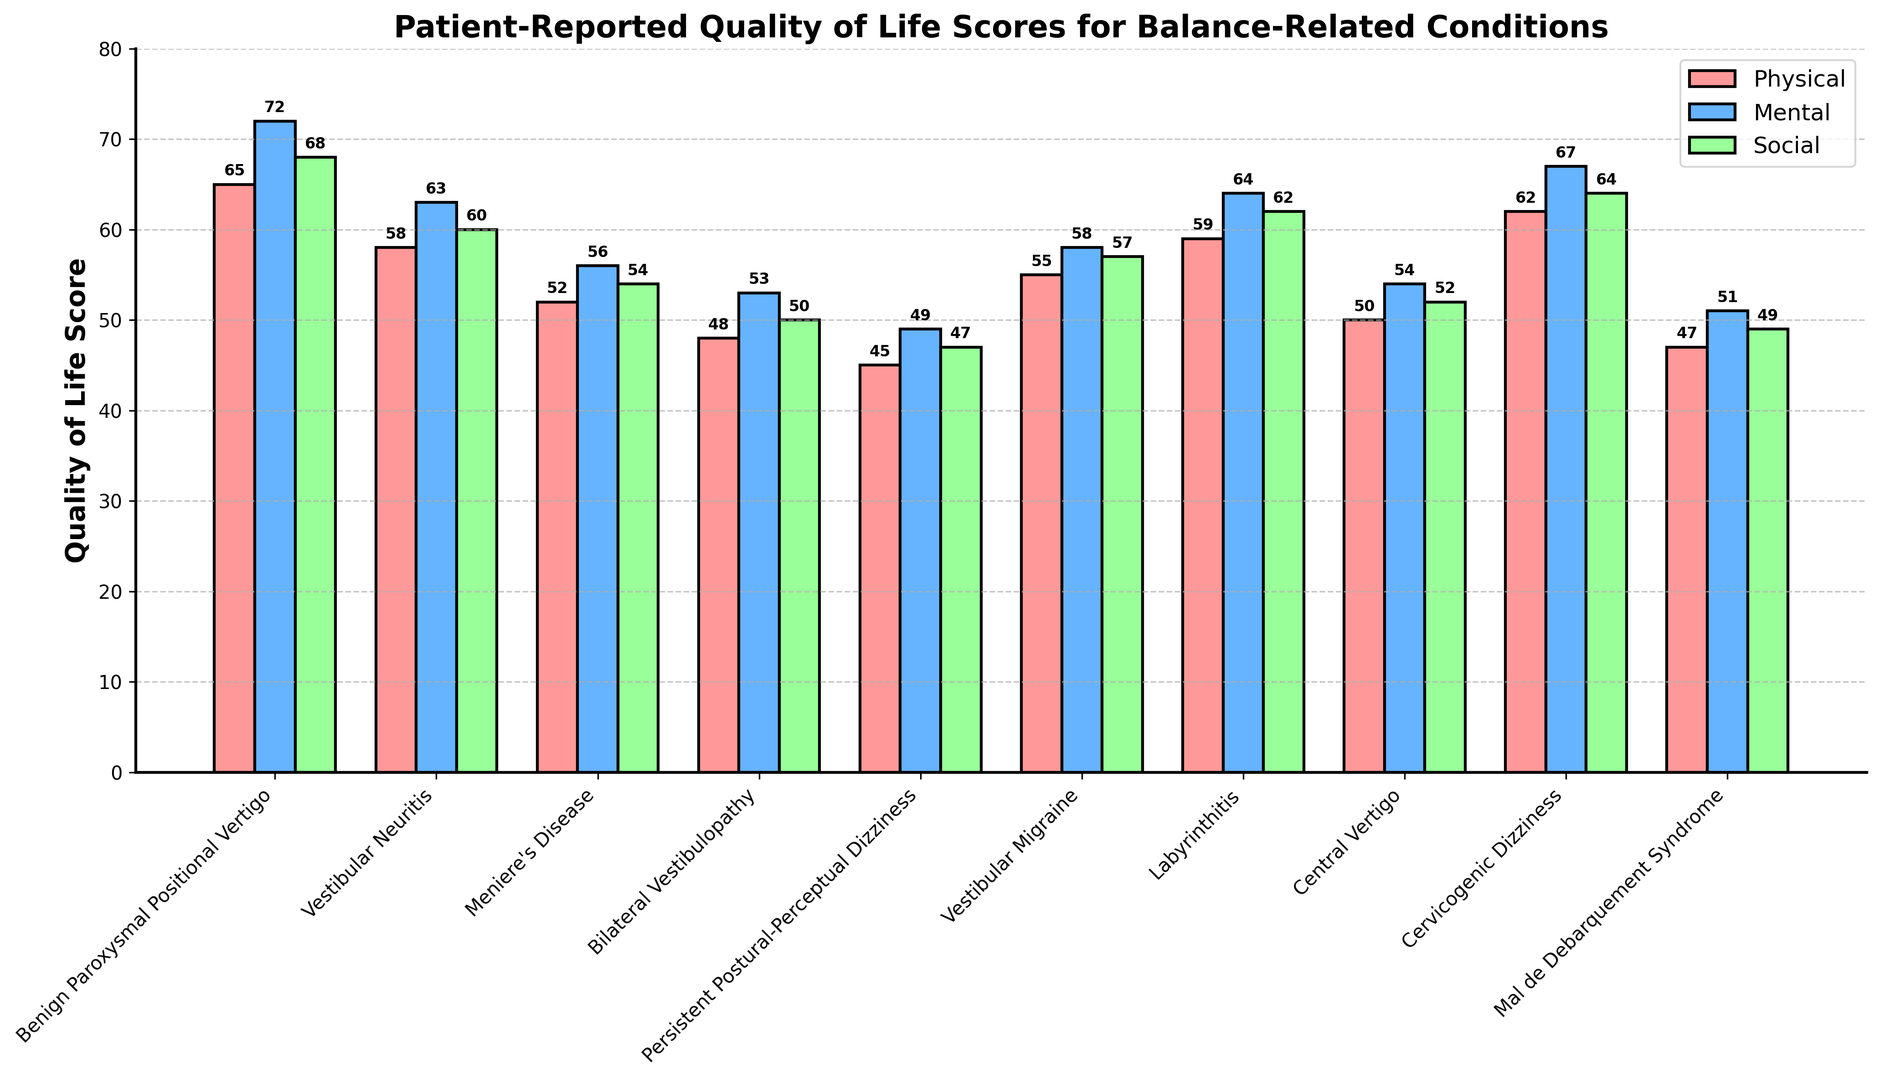What condition has the highest physical quality of life score? To find the condition with the highest physical quality of life score, look for the tallest bar in the "Physical" category (colored in red). The tallest bar represents "Benign Paroxysmal Positional Vertigo" with a score of 65.
Answer: Benign Paroxysmal Positional Vertigo Which condition has the lowest social quality of life score? To identify the condition with the lowest social quality of life score, look for the shortest bar in the "Social" category (colored in green). The shortest bar corresponds to "Persistent Postural-Perceptual Dizziness" with a score of 47.
Answer: Persistent Postural-Perceptual Dizziness What is the average mental quality of life score for Vestibular Migraine and Labyrinthitis? First, find the mental quality of life scores for Vestibular Migraine (58) and Labyrinthitis (64). Sum these scores: 58 + 64 = 122. Then, divide by the number of conditions (2): 122 / 2 = 61.
Answer: 61 Which condition shows a higher overall quality of life, Central Vertigo or Meniere's Disease? Compare the scores for all three categories (Physical, Mental, Social) for both conditions. Central Vertigo has scores of 50, 54, and 52 respectively, summing up to 156. Meniere's Disease has scores of 52, 56, and 54, summing up to 162. Meniere's Disease has a higher overall score.
Answer: Meniere's Disease How much higher is the physical quality of life score of Labyrinthitis compared to Bilateral Vestibulopathy? Find the physical scores for Labyrinthitis (59) and Bilateral Vestibulopathy (48). Subtract the score of Bilateral Vestibulopathy from Labyrinthitis: 59 - 48 = 11.
Answer: 11 What is the difference between the highest and lowest mental quality of life scores? Identify the highest mental quality of life score (72 for Benign Paroxysmal Positional Vertigo) and the lowest (49 for Persistent Postural-Perceptual Dizziness). Subtract the lowest from the highest: 72 - 49 = 23.
Answer: 23 Which condition has the smallest difference between its physical and mental quality of life scores? Calculate the differences between physical and mental scores for each condition and identify the smallest difference. The smallest difference is 3 for "Mal de Debarquement Syndrome" (Physical 47, Mental 51).
Answer: Mal de Debarquement Syndrome Does Cervicogenic Dizziness have higher scores than Vestibular Neuritis in all three categories? Compare the scores for Cervicogenic Dizziness (Physical 62, Mental 67, Social 64) with Vestibular Neuritis (Physical 58, Mental 63, Social 60). Cervicogenic Dizziness has higher scores in all three categories.
Answer: Yes What is the overall quality of life score (sum of Physical, Mental, and Social) for Central Vertigo? Sum the scores for Central Vertigo in each category: Physical (50) + Mental (54) + Social (52) = 156.
Answer: 156 